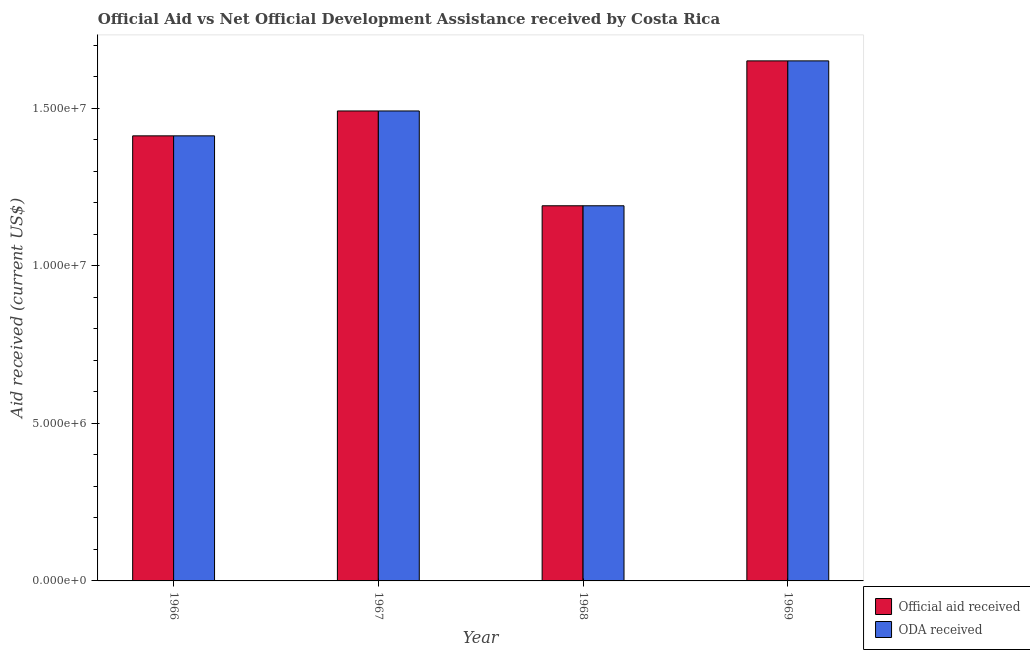How many different coloured bars are there?
Make the answer very short. 2. Are the number of bars per tick equal to the number of legend labels?
Make the answer very short. Yes. Are the number of bars on each tick of the X-axis equal?
Make the answer very short. Yes. How many bars are there on the 4th tick from the left?
Ensure brevity in your answer.  2. What is the label of the 4th group of bars from the left?
Your answer should be compact. 1969. What is the oda received in 1968?
Your answer should be compact. 1.19e+07. Across all years, what is the maximum oda received?
Offer a very short reply. 1.65e+07. Across all years, what is the minimum official aid received?
Provide a succinct answer. 1.19e+07. In which year was the oda received maximum?
Keep it short and to the point. 1969. In which year was the official aid received minimum?
Provide a succinct answer. 1968. What is the total oda received in the graph?
Your answer should be very brief. 5.75e+07. What is the difference between the oda received in 1966 and that in 1967?
Ensure brevity in your answer.  -7.90e+05. What is the difference between the official aid received in 1966 and the oda received in 1967?
Keep it short and to the point. -7.90e+05. What is the average oda received per year?
Provide a short and direct response. 1.44e+07. In the year 1969, what is the difference between the official aid received and oda received?
Your answer should be very brief. 0. In how many years, is the oda received greater than 1000000 US$?
Make the answer very short. 4. What is the ratio of the oda received in 1967 to that in 1968?
Ensure brevity in your answer.  1.25. Is the official aid received in 1967 less than that in 1968?
Provide a short and direct response. No. Is the difference between the oda received in 1967 and 1969 greater than the difference between the official aid received in 1967 and 1969?
Your response must be concise. No. What is the difference between the highest and the second highest oda received?
Your answer should be compact. 1.59e+06. What is the difference between the highest and the lowest oda received?
Offer a terse response. 4.60e+06. In how many years, is the oda received greater than the average oda received taken over all years?
Your response must be concise. 2. What does the 1st bar from the left in 1966 represents?
Give a very brief answer. Official aid received. What does the 2nd bar from the right in 1966 represents?
Your answer should be very brief. Official aid received. Are all the bars in the graph horizontal?
Your answer should be compact. No. How many years are there in the graph?
Provide a short and direct response. 4. What is the difference between two consecutive major ticks on the Y-axis?
Offer a very short reply. 5.00e+06. Are the values on the major ticks of Y-axis written in scientific E-notation?
Offer a terse response. Yes. Does the graph contain any zero values?
Give a very brief answer. No. Where does the legend appear in the graph?
Provide a succinct answer. Bottom right. How are the legend labels stacked?
Provide a succinct answer. Vertical. What is the title of the graph?
Your response must be concise. Official Aid vs Net Official Development Assistance received by Costa Rica . Does "2012 US$" appear as one of the legend labels in the graph?
Give a very brief answer. No. What is the label or title of the X-axis?
Provide a short and direct response. Year. What is the label or title of the Y-axis?
Offer a terse response. Aid received (current US$). What is the Aid received (current US$) of Official aid received in 1966?
Make the answer very short. 1.41e+07. What is the Aid received (current US$) in ODA received in 1966?
Provide a succinct answer. 1.41e+07. What is the Aid received (current US$) in Official aid received in 1967?
Your response must be concise. 1.49e+07. What is the Aid received (current US$) in ODA received in 1967?
Make the answer very short. 1.49e+07. What is the Aid received (current US$) of Official aid received in 1968?
Make the answer very short. 1.19e+07. What is the Aid received (current US$) in ODA received in 1968?
Offer a terse response. 1.19e+07. What is the Aid received (current US$) in Official aid received in 1969?
Your answer should be compact. 1.65e+07. What is the Aid received (current US$) of ODA received in 1969?
Offer a very short reply. 1.65e+07. Across all years, what is the maximum Aid received (current US$) of Official aid received?
Keep it short and to the point. 1.65e+07. Across all years, what is the maximum Aid received (current US$) of ODA received?
Provide a succinct answer. 1.65e+07. Across all years, what is the minimum Aid received (current US$) in Official aid received?
Your response must be concise. 1.19e+07. Across all years, what is the minimum Aid received (current US$) of ODA received?
Your answer should be very brief. 1.19e+07. What is the total Aid received (current US$) in Official aid received in the graph?
Your response must be concise. 5.75e+07. What is the total Aid received (current US$) of ODA received in the graph?
Offer a terse response. 5.75e+07. What is the difference between the Aid received (current US$) of Official aid received in 1966 and that in 1967?
Offer a very short reply. -7.90e+05. What is the difference between the Aid received (current US$) of ODA received in 1966 and that in 1967?
Provide a succinct answer. -7.90e+05. What is the difference between the Aid received (current US$) in Official aid received in 1966 and that in 1968?
Keep it short and to the point. 2.22e+06. What is the difference between the Aid received (current US$) in ODA received in 1966 and that in 1968?
Your response must be concise. 2.22e+06. What is the difference between the Aid received (current US$) of Official aid received in 1966 and that in 1969?
Your answer should be very brief. -2.38e+06. What is the difference between the Aid received (current US$) in ODA received in 1966 and that in 1969?
Your answer should be compact. -2.38e+06. What is the difference between the Aid received (current US$) in Official aid received in 1967 and that in 1968?
Give a very brief answer. 3.01e+06. What is the difference between the Aid received (current US$) of ODA received in 1967 and that in 1968?
Your answer should be compact. 3.01e+06. What is the difference between the Aid received (current US$) in Official aid received in 1967 and that in 1969?
Keep it short and to the point. -1.59e+06. What is the difference between the Aid received (current US$) of ODA received in 1967 and that in 1969?
Give a very brief answer. -1.59e+06. What is the difference between the Aid received (current US$) in Official aid received in 1968 and that in 1969?
Your response must be concise. -4.60e+06. What is the difference between the Aid received (current US$) of ODA received in 1968 and that in 1969?
Provide a short and direct response. -4.60e+06. What is the difference between the Aid received (current US$) in Official aid received in 1966 and the Aid received (current US$) in ODA received in 1967?
Your answer should be very brief. -7.90e+05. What is the difference between the Aid received (current US$) in Official aid received in 1966 and the Aid received (current US$) in ODA received in 1968?
Keep it short and to the point. 2.22e+06. What is the difference between the Aid received (current US$) of Official aid received in 1966 and the Aid received (current US$) of ODA received in 1969?
Your answer should be compact. -2.38e+06. What is the difference between the Aid received (current US$) of Official aid received in 1967 and the Aid received (current US$) of ODA received in 1968?
Ensure brevity in your answer.  3.01e+06. What is the difference between the Aid received (current US$) of Official aid received in 1967 and the Aid received (current US$) of ODA received in 1969?
Your response must be concise. -1.59e+06. What is the difference between the Aid received (current US$) of Official aid received in 1968 and the Aid received (current US$) of ODA received in 1969?
Keep it short and to the point. -4.60e+06. What is the average Aid received (current US$) in Official aid received per year?
Give a very brief answer. 1.44e+07. What is the average Aid received (current US$) in ODA received per year?
Give a very brief answer. 1.44e+07. In the year 1968, what is the difference between the Aid received (current US$) in Official aid received and Aid received (current US$) in ODA received?
Offer a terse response. 0. In the year 1969, what is the difference between the Aid received (current US$) in Official aid received and Aid received (current US$) in ODA received?
Provide a succinct answer. 0. What is the ratio of the Aid received (current US$) in Official aid received in 1966 to that in 1967?
Provide a short and direct response. 0.95. What is the ratio of the Aid received (current US$) of ODA received in 1966 to that in 1967?
Provide a succinct answer. 0.95. What is the ratio of the Aid received (current US$) in Official aid received in 1966 to that in 1968?
Your answer should be very brief. 1.19. What is the ratio of the Aid received (current US$) in ODA received in 1966 to that in 1968?
Keep it short and to the point. 1.19. What is the ratio of the Aid received (current US$) of Official aid received in 1966 to that in 1969?
Your answer should be compact. 0.86. What is the ratio of the Aid received (current US$) of ODA received in 1966 to that in 1969?
Provide a succinct answer. 0.86. What is the ratio of the Aid received (current US$) of Official aid received in 1967 to that in 1968?
Your answer should be compact. 1.25. What is the ratio of the Aid received (current US$) of ODA received in 1967 to that in 1968?
Offer a very short reply. 1.25. What is the ratio of the Aid received (current US$) in Official aid received in 1967 to that in 1969?
Give a very brief answer. 0.9. What is the ratio of the Aid received (current US$) in ODA received in 1967 to that in 1969?
Keep it short and to the point. 0.9. What is the ratio of the Aid received (current US$) of Official aid received in 1968 to that in 1969?
Your answer should be very brief. 0.72. What is the ratio of the Aid received (current US$) of ODA received in 1968 to that in 1969?
Keep it short and to the point. 0.72. What is the difference between the highest and the second highest Aid received (current US$) in Official aid received?
Your answer should be very brief. 1.59e+06. What is the difference between the highest and the second highest Aid received (current US$) of ODA received?
Give a very brief answer. 1.59e+06. What is the difference between the highest and the lowest Aid received (current US$) in Official aid received?
Make the answer very short. 4.60e+06. What is the difference between the highest and the lowest Aid received (current US$) of ODA received?
Ensure brevity in your answer.  4.60e+06. 